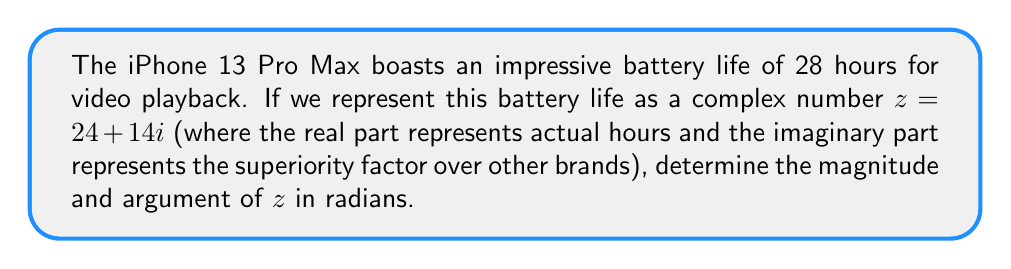Can you solve this math problem? To find the magnitude and argument of the complex number $z = 24 + 14i$, we'll follow these steps:

1. Calculate the magnitude:
   The magnitude is given by $|z| = \sqrt{a^2 + b^2}$, where $a$ is the real part and $b$ is the imaginary part.
   
   $$|z| = \sqrt{24^2 + 14^2} = \sqrt{576 + 196} = \sqrt{772} = 2\sqrt{193}$$

2. Calculate the argument:
   The argument is given by $\arg(z) = \tan^{-1}(\frac{b}{a})$, where $a$ is the real part and $b$ is the imaginary part.
   
   $$\arg(z) = \tan^{-1}(\frac{14}{24}) = \tan^{-1}(\frac{7}{12})$$

   To simplify this, we can use the arctangent function:
   
   $$\arg(z) = \arctan(\frac{7}{12}) \approx 0.5297$$

Therefore, the magnitude of $z$ is $2\sqrt{193}$, and the argument is approximately 0.5297 radians.
Answer: Magnitude: $2\sqrt{193}$, Argument: $\arctan(\frac{7}{12})$ radians 